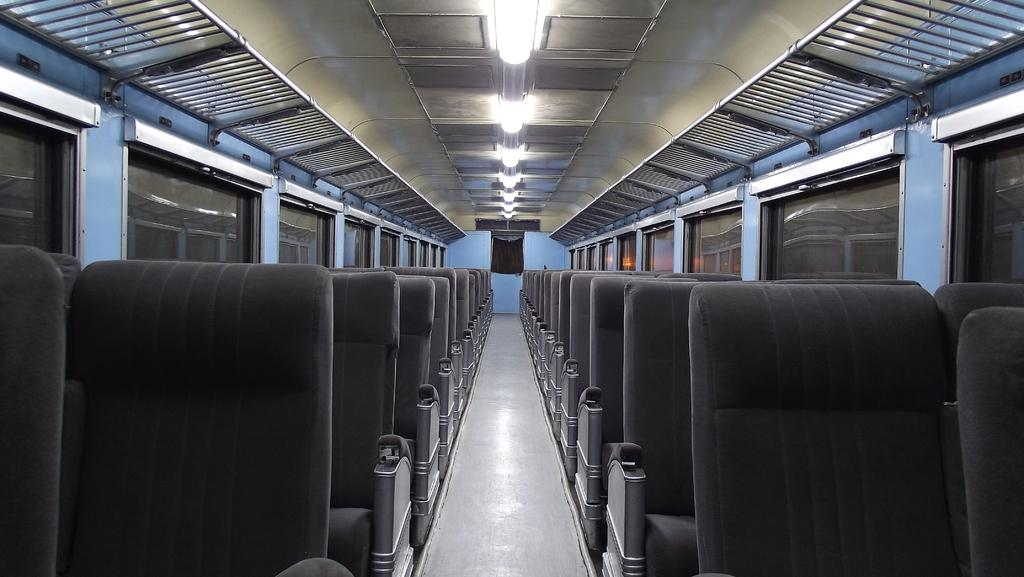What is the main subject of the image? The image shows the internal structure of a vehicle. What can be found inside the vehicle? There are seats in the vehicle. What feature allows passengers to see outside the vehicle? The vehicle has windows. What helps to illuminate the interior of the vehicle? There are lights in the vehicle. How can passengers store their luggage in the vehicle? There are racks to keep luggage bags in the vehicle. How many cats are sitting on the seats in the image? There are no cats present in the image; it shows the internal structure of a vehicle with seats, windows, lights, and luggage racks. 